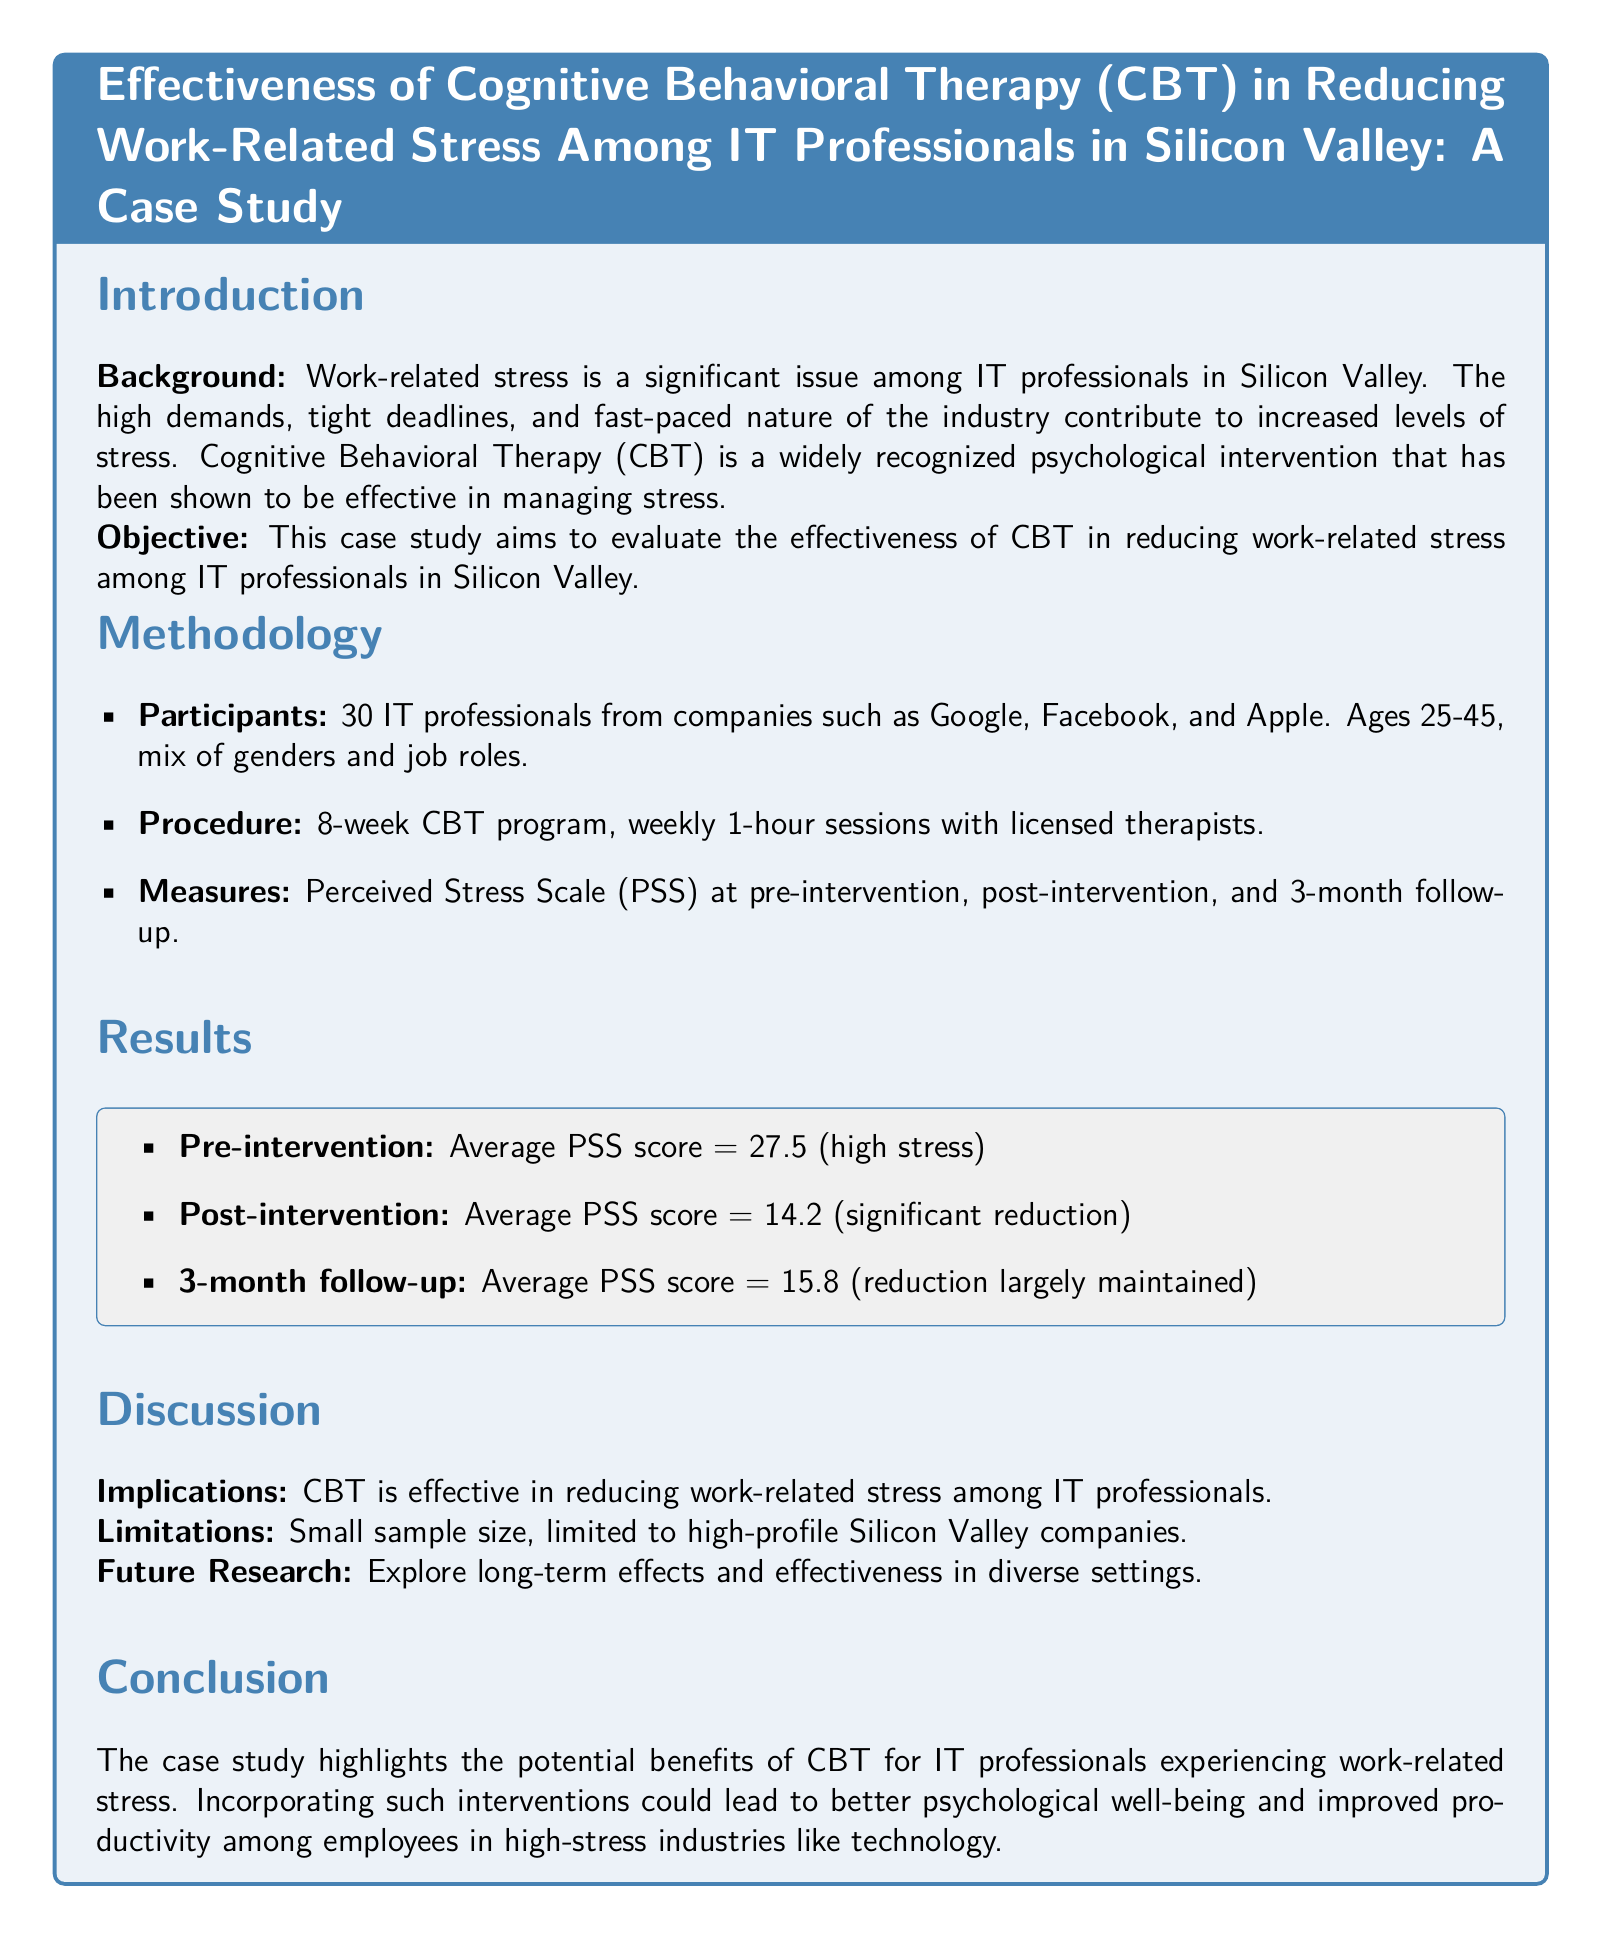What is the background focus of the case study? The background focuses on the significant issue of work-related stress among IT professionals in Silicon Valley.
Answer: work-related stress What is the average pre-intervention PSS score? The average pre-intervention PSS score, indicating high stress, is provided in the results section.
Answer: 27.5 How long was the CBT program conducted? The duration of the CBT program is mentioned in the methodology section.
Answer: 8 weeks What was the average PSS score at the 3-month follow-up? The average PSS score at the 3-month follow-up is listed in the results summary.
Answer: 15.8 What companies did the participants come from? The companies where participants were employed are mentioned in the methodology section.
Answer: Google, Facebook, Apple What is a major limitation noted in the case study? The limitations of the study specify aspects that could affect the findings.
Answer: Small sample size What type of therapy is evaluated in this case study? The therapy being evaluated is specified in the title and throughout the document.
Answer: Cognitive Behavioral Therapy What measure was used to assess stress levels? The document mentions the specific scale used to assess stress in the participants.
Answer: Perceived Stress Scale 